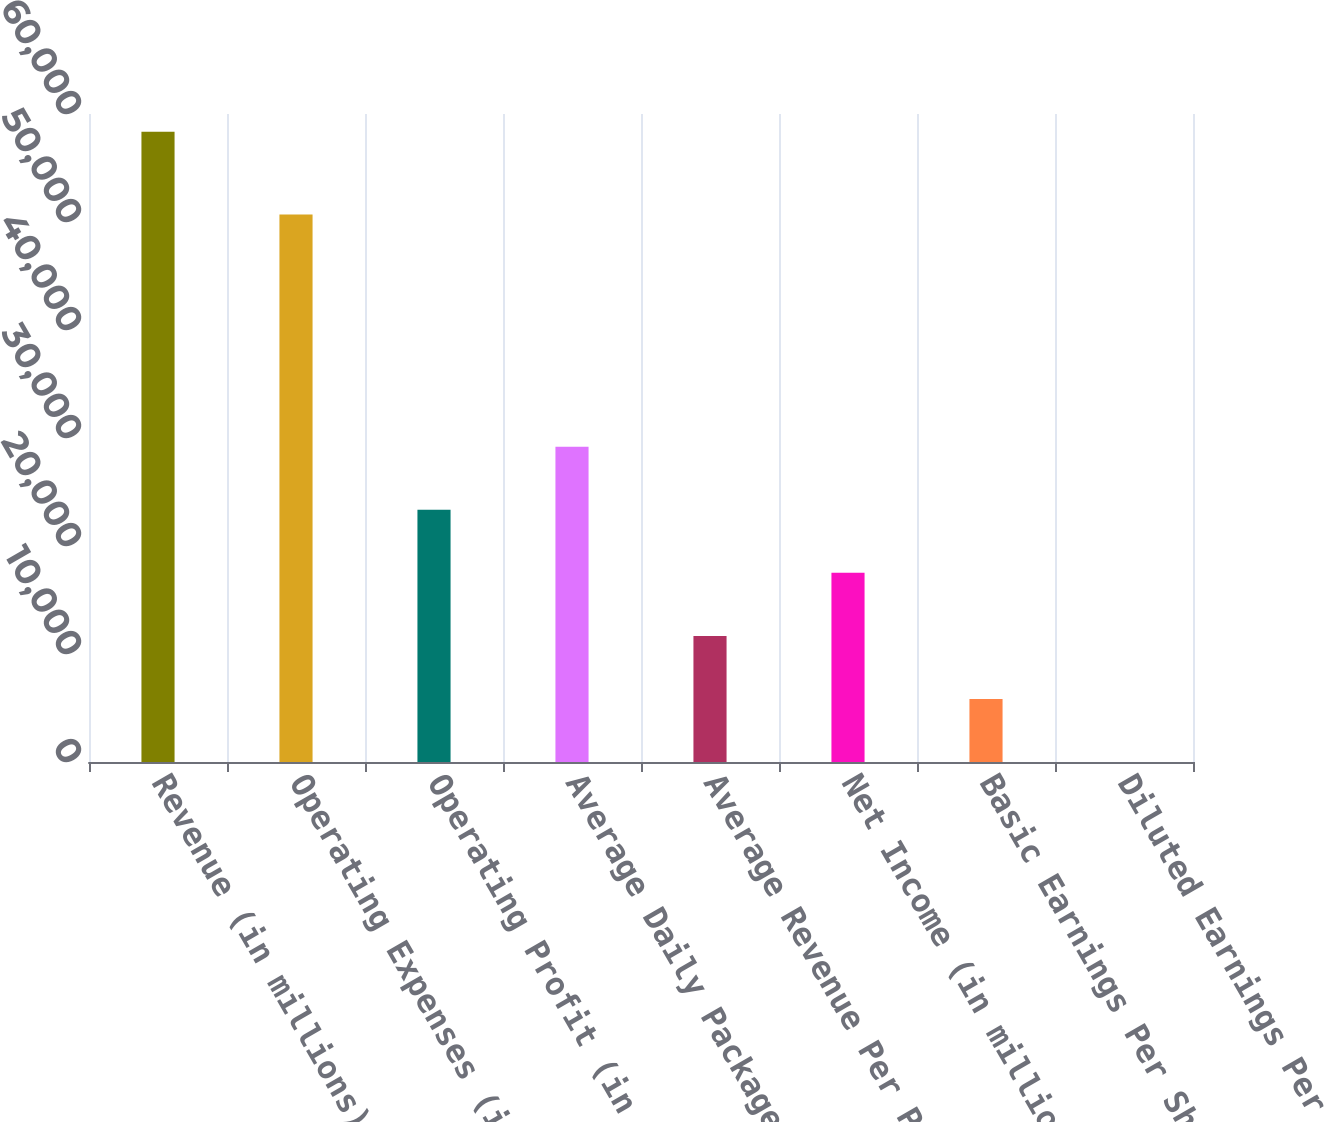Convert chart to OTSL. <chart><loc_0><loc_0><loc_500><loc_500><bar_chart><fcel>Revenue (in millions)<fcel>Operating Expenses (in<fcel>Operating Profit (in millions)<fcel>Average Daily Package Volume<fcel>Average Revenue Per Piece<fcel>Net Income (in millions)<fcel>Basic Earnings Per Share<fcel>Diluted Earnings Per Share<nl><fcel>58363<fcel>50695<fcel>23348.4<fcel>29184.2<fcel>11676.9<fcel>17512.7<fcel>5841.12<fcel>5.35<nl></chart> 